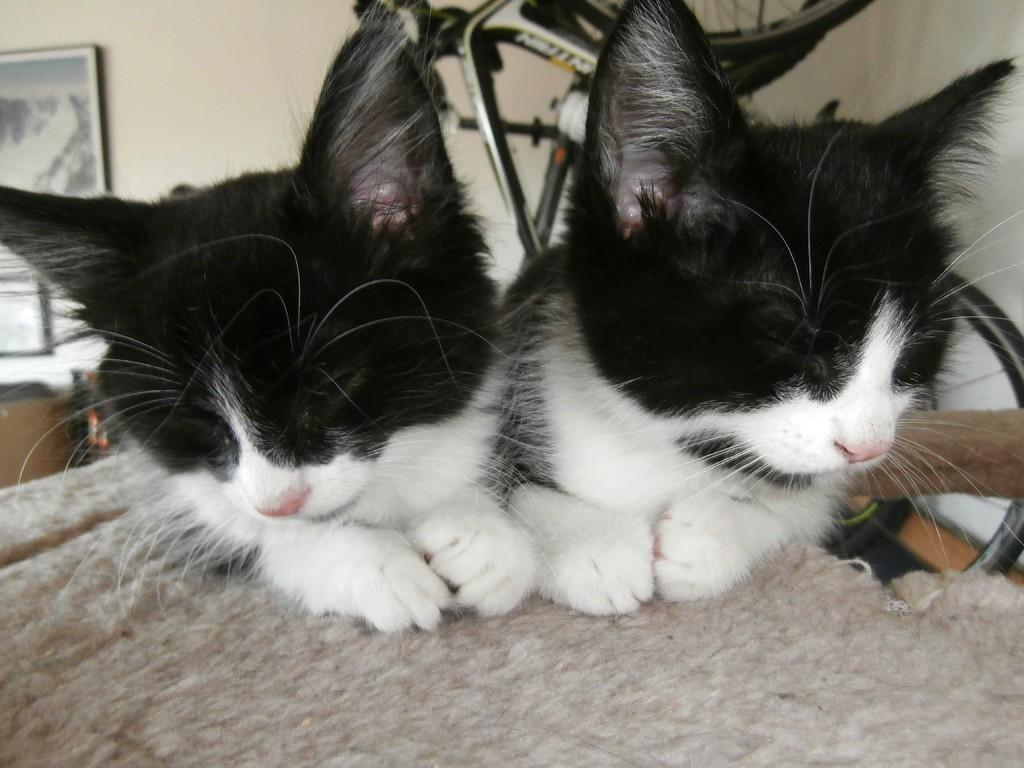What animals are in the foreground of the image? There are two cats in the foreground of the image. What surface are the cats on? The cats are on a mat. What can be seen in the background of the image? There is a wall, frames, and a bicycle in the background of the image. Reasoning: Let's think step by identifying the main subjects and objects in the image based on the provided facts. We then formulate questions that focus on the location and characteristics of these subjects and objects, ensuring that each question can be answered definitively with the information given. We avoid yes/no questions and ensure that the language is simple and clear. Absurd Question/Answer: Where is the basin located in the image? There is no basin present in the image. Can you see a swing in the background of the image? No, there is no swing present in the image. Are the cats slipping on the mat in the image? There is no indication in the image that the cats are slipping on the mat. 